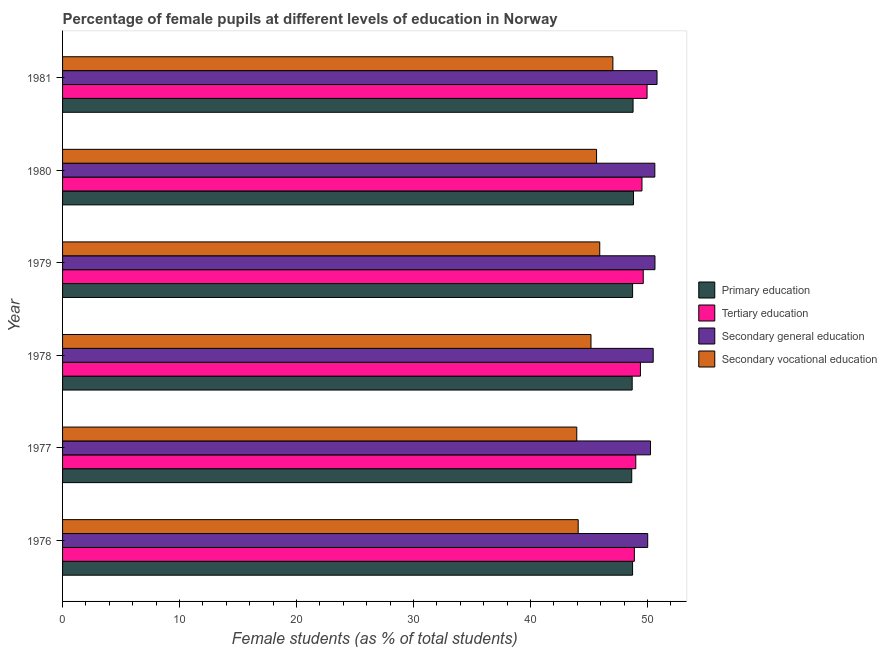How many different coloured bars are there?
Your answer should be very brief. 4. Are the number of bars per tick equal to the number of legend labels?
Offer a terse response. Yes. What is the label of the 6th group of bars from the top?
Provide a succinct answer. 1976. In how many cases, is the number of bars for a given year not equal to the number of legend labels?
Keep it short and to the point. 0. What is the percentage of female students in tertiary education in 1979?
Your response must be concise. 49.63. Across all years, what is the maximum percentage of female students in secondary vocational education?
Provide a short and direct response. 47.03. Across all years, what is the minimum percentage of female students in secondary vocational education?
Your answer should be very brief. 43.95. What is the total percentage of female students in secondary education in the graph?
Give a very brief answer. 302.8. What is the difference between the percentage of female students in primary education in 1977 and that in 1978?
Your answer should be very brief. -0.04. What is the difference between the percentage of female students in secondary education in 1979 and the percentage of female students in tertiary education in 1976?
Give a very brief answer. 1.76. What is the average percentage of female students in secondary education per year?
Your response must be concise. 50.47. In the year 1976, what is the difference between the percentage of female students in secondary vocational education and percentage of female students in secondary education?
Provide a short and direct response. -5.94. What is the difference between the highest and the second highest percentage of female students in secondary vocational education?
Your response must be concise. 1.12. What is the difference between the highest and the lowest percentage of female students in secondary vocational education?
Provide a short and direct response. 3.09. In how many years, is the percentage of female students in tertiary education greater than the average percentage of female students in tertiary education taken over all years?
Provide a succinct answer. 3. What does the 3rd bar from the top in 1977 represents?
Offer a terse response. Tertiary education. What does the 4th bar from the bottom in 1978 represents?
Your answer should be compact. Secondary vocational education. Are all the bars in the graph horizontal?
Give a very brief answer. Yes. How many years are there in the graph?
Offer a terse response. 6. What is the difference between two consecutive major ticks on the X-axis?
Make the answer very short. 10. Are the values on the major ticks of X-axis written in scientific E-notation?
Ensure brevity in your answer.  No. Does the graph contain any zero values?
Give a very brief answer. No. Where does the legend appear in the graph?
Ensure brevity in your answer.  Center right. How are the legend labels stacked?
Offer a very short reply. Vertical. What is the title of the graph?
Provide a short and direct response. Percentage of female pupils at different levels of education in Norway. Does "UNTA" appear as one of the legend labels in the graph?
Make the answer very short. No. What is the label or title of the X-axis?
Offer a terse response. Female students (as % of total students). What is the label or title of the Y-axis?
Your response must be concise. Year. What is the Female students (as % of total students) of Primary education in 1976?
Your answer should be compact. 48.72. What is the Female students (as % of total students) of Tertiary education in 1976?
Keep it short and to the point. 48.87. What is the Female students (as % of total students) in Secondary general education in 1976?
Offer a terse response. 50.01. What is the Female students (as % of total students) in Secondary vocational education in 1976?
Make the answer very short. 44.07. What is the Female students (as % of total students) in Primary education in 1977?
Keep it short and to the point. 48.65. What is the Female students (as % of total students) of Tertiary education in 1977?
Offer a terse response. 48.99. What is the Female students (as % of total students) of Secondary general education in 1977?
Give a very brief answer. 50.25. What is the Female students (as % of total students) of Secondary vocational education in 1977?
Keep it short and to the point. 43.95. What is the Female students (as % of total students) in Primary education in 1978?
Give a very brief answer. 48.68. What is the Female students (as % of total students) of Tertiary education in 1978?
Offer a very short reply. 49.39. What is the Female students (as % of total students) in Secondary general education in 1978?
Offer a very short reply. 50.48. What is the Female students (as % of total students) in Secondary vocational education in 1978?
Ensure brevity in your answer.  45.16. What is the Female students (as % of total students) in Primary education in 1979?
Provide a short and direct response. 48.72. What is the Female students (as % of total students) of Tertiary education in 1979?
Offer a terse response. 49.63. What is the Female students (as % of total students) in Secondary general education in 1979?
Offer a terse response. 50.63. What is the Female students (as % of total students) of Secondary vocational education in 1979?
Offer a very short reply. 45.91. What is the Female students (as % of total students) of Primary education in 1980?
Provide a short and direct response. 48.8. What is the Female students (as % of total students) in Tertiary education in 1980?
Keep it short and to the point. 49.52. What is the Female students (as % of total students) of Secondary general education in 1980?
Your answer should be very brief. 50.62. What is the Female students (as % of total students) in Secondary vocational education in 1980?
Your answer should be very brief. 45.64. What is the Female students (as % of total students) in Primary education in 1981?
Keep it short and to the point. 48.76. What is the Female students (as % of total students) in Tertiary education in 1981?
Provide a short and direct response. 49.96. What is the Female students (as % of total students) in Secondary general education in 1981?
Keep it short and to the point. 50.81. What is the Female students (as % of total students) of Secondary vocational education in 1981?
Your response must be concise. 47.03. Across all years, what is the maximum Female students (as % of total students) in Primary education?
Provide a short and direct response. 48.8. Across all years, what is the maximum Female students (as % of total students) in Tertiary education?
Ensure brevity in your answer.  49.96. Across all years, what is the maximum Female students (as % of total students) in Secondary general education?
Provide a short and direct response. 50.81. Across all years, what is the maximum Female students (as % of total students) of Secondary vocational education?
Your answer should be compact. 47.03. Across all years, what is the minimum Female students (as % of total students) of Primary education?
Your answer should be compact. 48.65. Across all years, what is the minimum Female students (as % of total students) in Tertiary education?
Offer a terse response. 48.87. Across all years, what is the minimum Female students (as % of total students) of Secondary general education?
Your answer should be very brief. 50.01. Across all years, what is the minimum Female students (as % of total students) of Secondary vocational education?
Your response must be concise. 43.95. What is the total Female students (as % of total students) of Primary education in the graph?
Give a very brief answer. 292.32. What is the total Female students (as % of total students) in Tertiary education in the graph?
Give a very brief answer. 296.35. What is the total Female students (as % of total students) of Secondary general education in the graph?
Ensure brevity in your answer.  302.8. What is the total Female students (as % of total students) in Secondary vocational education in the graph?
Keep it short and to the point. 271.76. What is the difference between the Female students (as % of total students) of Primary education in 1976 and that in 1977?
Make the answer very short. 0.07. What is the difference between the Female students (as % of total students) of Tertiary education in 1976 and that in 1977?
Ensure brevity in your answer.  -0.12. What is the difference between the Female students (as % of total students) of Secondary general education in 1976 and that in 1977?
Offer a terse response. -0.24. What is the difference between the Female students (as % of total students) in Secondary vocational education in 1976 and that in 1977?
Keep it short and to the point. 0.12. What is the difference between the Female students (as % of total students) of Primary education in 1976 and that in 1978?
Keep it short and to the point. 0.03. What is the difference between the Female students (as % of total students) in Tertiary education in 1976 and that in 1978?
Keep it short and to the point. -0.52. What is the difference between the Female students (as % of total students) of Secondary general education in 1976 and that in 1978?
Keep it short and to the point. -0.47. What is the difference between the Female students (as % of total students) in Secondary vocational education in 1976 and that in 1978?
Offer a terse response. -1.09. What is the difference between the Female students (as % of total students) of Primary education in 1976 and that in 1979?
Make the answer very short. -0. What is the difference between the Female students (as % of total students) in Tertiary education in 1976 and that in 1979?
Keep it short and to the point. -0.76. What is the difference between the Female students (as % of total students) in Secondary general education in 1976 and that in 1979?
Your answer should be compact. -0.62. What is the difference between the Female students (as % of total students) in Secondary vocational education in 1976 and that in 1979?
Offer a terse response. -1.84. What is the difference between the Female students (as % of total students) in Primary education in 1976 and that in 1980?
Ensure brevity in your answer.  -0.08. What is the difference between the Female students (as % of total students) of Tertiary education in 1976 and that in 1980?
Ensure brevity in your answer.  -0.65. What is the difference between the Female students (as % of total students) in Secondary general education in 1976 and that in 1980?
Offer a very short reply. -0.61. What is the difference between the Female students (as % of total students) in Secondary vocational education in 1976 and that in 1980?
Your response must be concise. -1.57. What is the difference between the Female students (as % of total students) in Primary education in 1976 and that in 1981?
Make the answer very short. -0.04. What is the difference between the Female students (as % of total students) of Tertiary education in 1976 and that in 1981?
Ensure brevity in your answer.  -1.09. What is the difference between the Female students (as % of total students) in Secondary general education in 1976 and that in 1981?
Offer a very short reply. -0.8. What is the difference between the Female students (as % of total students) of Secondary vocational education in 1976 and that in 1981?
Keep it short and to the point. -2.97. What is the difference between the Female students (as % of total students) in Primary education in 1977 and that in 1978?
Make the answer very short. -0.04. What is the difference between the Female students (as % of total students) in Tertiary education in 1977 and that in 1978?
Give a very brief answer. -0.4. What is the difference between the Female students (as % of total students) of Secondary general education in 1977 and that in 1978?
Offer a terse response. -0.23. What is the difference between the Female students (as % of total students) in Secondary vocational education in 1977 and that in 1978?
Your answer should be compact. -1.22. What is the difference between the Female students (as % of total students) in Primary education in 1977 and that in 1979?
Provide a succinct answer. -0.07. What is the difference between the Female students (as % of total students) of Tertiary education in 1977 and that in 1979?
Offer a terse response. -0.64. What is the difference between the Female students (as % of total students) of Secondary general education in 1977 and that in 1979?
Provide a succinct answer. -0.38. What is the difference between the Female students (as % of total students) of Secondary vocational education in 1977 and that in 1979?
Your answer should be compact. -1.96. What is the difference between the Female students (as % of total students) in Primary education in 1977 and that in 1980?
Your answer should be very brief. -0.15. What is the difference between the Female students (as % of total students) in Tertiary education in 1977 and that in 1980?
Your response must be concise. -0.53. What is the difference between the Female students (as % of total students) of Secondary general education in 1977 and that in 1980?
Keep it short and to the point. -0.37. What is the difference between the Female students (as % of total students) in Secondary vocational education in 1977 and that in 1980?
Your answer should be very brief. -1.69. What is the difference between the Female students (as % of total students) of Primary education in 1977 and that in 1981?
Provide a short and direct response. -0.11. What is the difference between the Female students (as % of total students) in Tertiary education in 1977 and that in 1981?
Give a very brief answer. -0.96. What is the difference between the Female students (as % of total students) in Secondary general education in 1977 and that in 1981?
Provide a short and direct response. -0.56. What is the difference between the Female students (as % of total students) in Secondary vocational education in 1977 and that in 1981?
Make the answer very short. -3.09. What is the difference between the Female students (as % of total students) in Primary education in 1978 and that in 1979?
Provide a short and direct response. -0.04. What is the difference between the Female students (as % of total students) in Tertiary education in 1978 and that in 1979?
Your response must be concise. -0.24. What is the difference between the Female students (as % of total students) in Secondary general education in 1978 and that in 1979?
Your response must be concise. -0.15. What is the difference between the Female students (as % of total students) of Secondary vocational education in 1978 and that in 1979?
Keep it short and to the point. -0.75. What is the difference between the Female students (as % of total students) of Primary education in 1978 and that in 1980?
Give a very brief answer. -0.11. What is the difference between the Female students (as % of total students) in Tertiary education in 1978 and that in 1980?
Provide a short and direct response. -0.13. What is the difference between the Female students (as % of total students) of Secondary general education in 1978 and that in 1980?
Make the answer very short. -0.14. What is the difference between the Female students (as % of total students) of Secondary vocational education in 1978 and that in 1980?
Ensure brevity in your answer.  -0.48. What is the difference between the Female students (as % of total students) of Primary education in 1978 and that in 1981?
Give a very brief answer. -0.08. What is the difference between the Female students (as % of total students) in Tertiary education in 1978 and that in 1981?
Your answer should be very brief. -0.57. What is the difference between the Female students (as % of total students) in Secondary general education in 1978 and that in 1981?
Your answer should be very brief. -0.33. What is the difference between the Female students (as % of total students) of Secondary vocational education in 1978 and that in 1981?
Offer a terse response. -1.87. What is the difference between the Female students (as % of total students) of Primary education in 1979 and that in 1980?
Offer a terse response. -0.08. What is the difference between the Female students (as % of total students) in Tertiary education in 1979 and that in 1980?
Offer a very short reply. 0.11. What is the difference between the Female students (as % of total students) of Secondary general education in 1979 and that in 1980?
Offer a very short reply. 0.01. What is the difference between the Female students (as % of total students) in Secondary vocational education in 1979 and that in 1980?
Provide a short and direct response. 0.27. What is the difference between the Female students (as % of total students) in Primary education in 1979 and that in 1981?
Your response must be concise. -0.04. What is the difference between the Female students (as % of total students) of Tertiary education in 1979 and that in 1981?
Your response must be concise. -0.33. What is the difference between the Female students (as % of total students) in Secondary general education in 1979 and that in 1981?
Your answer should be compact. -0.18. What is the difference between the Female students (as % of total students) in Secondary vocational education in 1979 and that in 1981?
Make the answer very short. -1.12. What is the difference between the Female students (as % of total students) in Primary education in 1980 and that in 1981?
Offer a very short reply. 0.04. What is the difference between the Female students (as % of total students) of Tertiary education in 1980 and that in 1981?
Provide a succinct answer. -0.44. What is the difference between the Female students (as % of total students) in Secondary general education in 1980 and that in 1981?
Your answer should be compact. -0.19. What is the difference between the Female students (as % of total students) in Secondary vocational education in 1980 and that in 1981?
Your answer should be very brief. -1.4. What is the difference between the Female students (as % of total students) in Primary education in 1976 and the Female students (as % of total students) in Tertiary education in 1977?
Give a very brief answer. -0.27. What is the difference between the Female students (as % of total students) of Primary education in 1976 and the Female students (as % of total students) of Secondary general education in 1977?
Your answer should be compact. -1.53. What is the difference between the Female students (as % of total students) in Primary education in 1976 and the Female students (as % of total students) in Secondary vocational education in 1977?
Your response must be concise. 4.77. What is the difference between the Female students (as % of total students) in Tertiary education in 1976 and the Female students (as % of total students) in Secondary general education in 1977?
Your answer should be very brief. -1.38. What is the difference between the Female students (as % of total students) in Tertiary education in 1976 and the Female students (as % of total students) in Secondary vocational education in 1977?
Ensure brevity in your answer.  4.92. What is the difference between the Female students (as % of total students) in Secondary general education in 1976 and the Female students (as % of total students) in Secondary vocational education in 1977?
Ensure brevity in your answer.  6.06. What is the difference between the Female students (as % of total students) in Primary education in 1976 and the Female students (as % of total students) in Tertiary education in 1978?
Give a very brief answer. -0.67. What is the difference between the Female students (as % of total students) of Primary education in 1976 and the Female students (as % of total students) of Secondary general education in 1978?
Provide a succinct answer. -1.76. What is the difference between the Female students (as % of total students) of Primary education in 1976 and the Female students (as % of total students) of Secondary vocational education in 1978?
Your response must be concise. 3.55. What is the difference between the Female students (as % of total students) in Tertiary education in 1976 and the Female students (as % of total students) in Secondary general education in 1978?
Offer a very short reply. -1.61. What is the difference between the Female students (as % of total students) in Tertiary education in 1976 and the Female students (as % of total students) in Secondary vocational education in 1978?
Provide a succinct answer. 3.71. What is the difference between the Female students (as % of total students) in Secondary general education in 1976 and the Female students (as % of total students) in Secondary vocational education in 1978?
Keep it short and to the point. 4.85. What is the difference between the Female students (as % of total students) of Primary education in 1976 and the Female students (as % of total students) of Tertiary education in 1979?
Provide a succinct answer. -0.91. What is the difference between the Female students (as % of total students) of Primary education in 1976 and the Female students (as % of total students) of Secondary general education in 1979?
Ensure brevity in your answer.  -1.91. What is the difference between the Female students (as % of total students) in Primary education in 1976 and the Female students (as % of total students) in Secondary vocational education in 1979?
Your response must be concise. 2.81. What is the difference between the Female students (as % of total students) in Tertiary education in 1976 and the Female students (as % of total students) in Secondary general education in 1979?
Your response must be concise. -1.76. What is the difference between the Female students (as % of total students) in Tertiary education in 1976 and the Female students (as % of total students) in Secondary vocational education in 1979?
Give a very brief answer. 2.96. What is the difference between the Female students (as % of total students) of Secondary general education in 1976 and the Female students (as % of total students) of Secondary vocational education in 1979?
Keep it short and to the point. 4.1. What is the difference between the Female students (as % of total students) in Primary education in 1976 and the Female students (as % of total students) in Tertiary education in 1980?
Offer a terse response. -0.8. What is the difference between the Female students (as % of total students) in Primary education in 1976 and the Female students (as % of total students) in Secondary general education in 1980?
Give a very brief answer. -1.9. What is the difference between the Female students (as % of total students) of Primary education in 1976 and the Female students (as % of total students) of Secondary vocational education in 1980?
Keep it short and to the point. 3.08. What is the difference between the Female students (as % of total students) of Tertiary education in 1976 and the Female students (as % of total students) of Secondary general education in 1980?
Ensure brevity in your answer.  -1.75. What is the difference between the Female students (as % of total students) of Tertiary education in 1976 and the Female students (as % of total students) of Secondary vocational education in 1980?
Offer a terse response. 3.23. What is the difference between the Female students (as % of total students) in Secondary general education in 1976 and the Female students (as % of total students) in Secondary vocational education in 1980?
Provide a succinct answer. 4.37. What is the difference between the Female students (as % of total students) of Primary education in 1976 and the Female students (as % of total students) of Tertiary education in 1981?
Give a very brief answer. -1.24. What is the difference between the Female students (as % of total students) in Primary education in 1976 and the Female students (as % of total students) in Secondary general education in 1981?
Keep it short and to the point. -2.09. What is the difference between the Female students (as % of total students) in Primary education in 1976 and the Female students (as % of total students) in Secondary vocational education in 1981?
Your response must be concise. 1.68. What is the difference between the Female students (as % of total students) of Tertiary education in 1976 and the Female students (as % of total students) of Secondary general education in 1981?
Give a very brief answer. -1.94. What is the difference between the Female students (as % of total students) of Tertiary education in 1976 and the Female students (as % of total students) of Secondary vocational education in 1981?
Your answer should be very brief. 1.84. What is the difference between the Female students (as % of total students) of Secondary general education in 1976 and the Female students (as % of total students) of Secondary vocational education in 1981?
Make the answer very short. 2.98. What is the difference between the Female students (as % of total students) in Primary education in 1977 and the Female students (as % of total students) in Tertiary education in 1978?
Provide a succinct answer. -0.74. What is the difference between the Female students (as % of total students) of Primary education in 1977 and the Female students (as % of total students) of Secondary general education in 1978?
Offer a terse response. -1.83. What is the difference between the Female students (as % of total students) in Primary education in 1977 and the Female students (as % of total students) in Secondary vocational education in 1978?
Provide a succinct answer. 3.48. What is the difference between the Female students (as % of total students) of Tertiary education in 1977 and the Female students (as % of total students) of Secondary general education in 1978?
Offer a terse response. -1.49. What is the difference between the Female students (as % of total students) in Tertiary education in 1977 and the Female students (as % of total students) in Secondary vocational education in 1978?
Your answer should be very brief. 3.83. What is the difference between the Female students (as % of total students) of Secondary general education in 1977 and the Female students (as % of total students) of Secondary vocational education in 1978?
Your answer should be compact. 5.09. What is the difference between the Female students (as % of total students) of Primary education in 1977 and the Female students (as % of total students) of Tertiary education in 1979?
Your response must be concise. -0.98. What is the difference between the Female students (as % of total students) of Primary education in 1977 and the Female students (as % of total students) of Secondary general education in 1979?
Your answer should be compact. -1.99. What is the difference between the Female students (as % of total students) of Primary education in 1977 and the Female students (as % of total students) of Secondary vocational education in 1979?
Offer a very short reply. 2.73. What is the difference between the Female students (as % of total students) in Tertiary education in 1977 and the Female students (as % of total students) in Secondary general education in 1979?
Give a very brief answer. -1.64. What is the difference between the Female students (as % of total students) in Tertiary education in 1977 and the Female students (as % of total students) in Secondary vocational education in 1979?
Provide a succinct answer. 3.08. What is the difference between the Female students (as % of total students) in Secondary general education in 1977 and the Female students (as % of total students) in Secondary vocational education in 1979?
Your answer should be very brief. 4.34. What is the difference between the Female students (as % of total students) in Primary education in 1977 and the Female students (as % of total students) in Tertiary education in 1980?
Keep it short and to the point. -0.87. What is the difference between the Female students (as % of total students) of Primary education in 1977 and the Female students (as % of total students) of Secondary general education in 1980?
Provide a short and direct response. -1.97. What is the difference between the Female students (as % of total students) in Primary education in 1977 and the Female students (as % of total students) in Secondary vocational education in 1980?
Your response must be concise. 3.01. What is the difference between the Female students (as % of total students) in Tertiary education in 1977 and the Female students (as % of total students) in Secondary general education in 1980?
Ensure brevity in your answer.  -1.63. What is the difference between the Female students (as % of total students) in Tertiary education in 1977 and the Female students (as % of total students) in Secondary vocational education in 1980?
Provide a short and direct response. 3.35. What is the difference between the Female students (as % of total students) of Secondary general education in 1977 and the Female students (as % of total students) of Secondary vocational education in 1980?
Make the answer very short. 4.61. What is the difference between the Female students (as % of total students) of Primary education in 1977 and the Female students (as % of total students) of Tertiary education in 1981?
Provide a succinct answer. -1.31. What is the difference between the Female students (as % of total students) in Primary education in 1977 and the Female students (as % of total students) in Secondary general education in 1981?
Provide a short and direct response. -2.16. What is the difference between the Female students (as % of total students) of Primary education in 1977 and the Female students (as % of total students) of Secondary vocational education in 1981?
Your answer should be compact. 1.61. What is the difference between the Female students (as % of total students) in Tertiary education in 1977 and the Female students (as % of total students) in Secondary general education in 1981?
Give a very brief answer. -1.82. What is the difference between the Female students (as % of total students) of Tertiary education in 1977 and the Female students (as % of total students) of Secondary vocational education in 1981?
Your answer should be very brief. 1.96. What is the difference between the Female students (as % of total students) of Secondary general education in 1977 and the Female students (as % of total students) of Secondary vocational education in 1981?
Make the answer very short. 3.21. What is the difference between the Female students (as % of total students) in Primary education in 1978 and the Female students (as % of total students) in Tertiary education in 1979?
Your answer should be compact. -0.95. What is the difference between the Female students (as % of total students) of Primary education in 1978 and the Female students (as % of total students) of Secondary general education in 1979?
Keep it short and to the point. -1.95. What is the difference between the Female students (as % of total students) of Primary education in 1978 and the Female students (as % of total students) of Secondary vocational education in 1979?
Ensure brevity in your answer.  2.77. What is the difference between the Female students (as % of total students) of Tertiary education in 1978 and the Female students (as % of total students) of Secondary general education in 1979?
Offer a terse response. -1.24. What is the difference between the Female students (as % of total students) in Tertiary education in 1978 and the Female students (as % of total students) in Secondary vocational education in 1979?
Your answer should be very brief. 3.48. What is the difference between the Female students (as % of total students) in Secondary general education in 1978 and the Female students (as % of total students) in Secondary vocational education in 1979?
Provide a succinct answer. 4.57. What is the difference between the Female students (as % of total students) in Primary education in 1978 and the Female students (as % of total students) in Tertiary education in 1980?
Give a very brief answer. -0.84. What is the difference between the Female students (as % of total students) in Primary education in 1978 and the Female students (as % of total students) in Secondary general education in 1980?
Offer a terse response. -1.94. What is the difference between the Female students (as % of total students) in Primary education in 1978 and the Female students (as % of total students) in Secondary vocational education in 1980?
Provide a succinct answer. 3.04. What is the difference between the Female students (as % of total students) of Tertiary education in 1978 and the Female students (as % of total students) of Secondary general education in 1980?
Provide a short and direct response. -1.23. What is the difference between the Female students (as % of total students) in Tertiary education in 1978 and the Female students (as % of total students) in Secondary vocational education in 1980?
Offer a terse response. 3.75. What is the difference between the Female students (as % of total students) of Secondary general education in 1978 and the Female students (as % of total students) of Secondary vocational education in 1980?
Your response must be concise. 4.84. What is the difference between the Female students (as % of total students) of Primary education in 1978 and the Female students (as % of total students) of Tertiary education in 1981?
Your response must be concise. -1.27. What is the difference between the Female students (as % of total students) of Primary education in 1978 and the Female students (as % of total students) of Secondary general education in 1981?
Make the answer very short. -2.12. What is the difference between the Female students (as % of total students) in Primary education in 1978 and the Female students (as % of total students) in Secondary vocational education in 1981?
Offer a terse response. 1.65. What is the difference between the Female students (as % of total students) in Tertiary education in 1978 and the Female students (as % of total students) in Secondary general education in 1981?
Your answer should be compact. -1.42. What is the difference between the Female students (as % of total students) of Tertiary education in 1978 and the Female students (as % of total students) of Secondary vocational education in 1981?
Your response must be concise. 2.35. What is the difference between the Female students (as % of total students) in Secondary general education in 1978 and the Female students (as % of total students) in Secondary vocational education in 1981?
Your answer should be compact. 3.45. What is the difference between the Female students (as % of total students) of Primary education in 1979 and the Female students (as % of total students) of Tertiary education in 1980?
Your response must be concise. -0.8. What is the difference between the Female students (as % of total students) of Primary education in 1979 and the Female students (as % of total students) of Secondary general education in 1980?
Make the answer very short. -1.9. What is the difference between the Female students (as % of total students) of Primary education in 1979 and the Female students (as % of total students) of Secondary vocational education in 1980?
Keep it short and to the point. 3.08. What is the difference between the Female students (as % of total students) of Tertiary education in 1979 and the Female students (as % of total students) of Secondary general education in 1980?
Your response must be concise. -0.99. What is the difference between the Female students (as % of total students) in Tertiary education in 1979 and the Female students (as % of total students) in Secondary vocational education in 1980?
Your answer should be compact. 3.99. What is the difference between the Female students (as % of total students) of Secondary general education in 1979 and the Female students (as % of total students) of Secondary vocational education in 1980?
Ensure brevity in your answer.  4.99. What is the difference between the Female students (as % of total students) in Primary education in 1979 and the Female students (as % of total students) in Tertiary education in 1981?
Ensure brevity in your answer.  -1.24. What is the difference between the Female students (as % of total students) in Primary education in 1979 and the Female students (as % of total students) in Secondary general education in 1981?
Ensure brevity in your answer.  -2.09. What is the difference between the Female students (as % of total students) of Primary education in 1979 and the Female students (as % of total students) of Secondary vocational education in 1981?
Ensure brevity in your answer.  1.68. What is the difference between the Female students (as % of total students) in Tertiary education in 1979 and the Female students (as % of total students) in Secondary general education in 1981?
Keep it short and to the point. -1.18. What is the difference between the Female students (as % of total students) of Tertiary education in 1979 and the Female students (as % of total students) of Secondary vocational education in 1981?
Your response must be concise. 2.59. What is the difference between the Female students (as % of total students) of Secondary general education in 1979 and the Female students (as % of total students) of Secondary vocational education in 1981?
Your response must be concise. 3.6. What is the difference between the Female students (as % of total students) of Primary education in 1980 and the Female students (as % of total students) of Tertiary education in 1981?
Keep it short and to the point. -1.16. What is the difference between the Female students (as % of total students) of Primary education in 1980 and the Female students (as % of total students) of Secondary general education in 1981?
Keep it short and to the point. -2.01. What is the difference between the Female students (as % of total students) in Primary education in 1980 and the Female students (as % of total students) in Secondary vocational education in 1981?
Ensure brevity in your answer.  1.76. What is the difference between the Female students (as % of total students) in Tertiary education in 1980 and the Female students (as % of total students) in Secondary general education in 1981?
Your answer should be compact. -1.29. What is the difference between the Female students (as % of total students) of Tertiary education in 1980 and the Female students (as % of total students) of Secondary vocational education in 1981?
Offer a very short reply. 2.48. What is the difference between the Female students (as % of total students) in Secondary general education in 1980 and the Female students (as % of total students) in Secondary vocational education in 1981?
Ensure brevity in your answer.  3.58. What is the average Female students (as % of total students) in Primary education per year?
Give a very brief answer. 48.72. What is the average Female students (as % of total students) in Tertiary education per year?
Offer a very short reply. 49.39. What is the average Female students (as % of total students) in Secondary general education per year?
Offer a terse response. 50.47. What is the average Female students (as % of total students) in Secondary vocational education per year?
Your response must be concise. 45.29. In the year 1976, what is the difference between the Female students (as % of total students) of Primary education and Female students (as % of total students) of Tertiary education?
Your response must be concise. -0.15. In the year 1976, what is the difference between the Female students (as % of total students) of Primary education and Female students (as % of total students) of Secondary general education?
Provide a succinct answer. -1.29. In the year 1976, what is the difference between the Female students (as % of total students) in Primary education and Female students (as % of total students) in Secondary vocational education?
Provide a succinct answer. 4.65. In the year 1976, what is the difference between the Female students (as % of total students) in Tertiary education and Female students (as % of total students) in Secondary general education?
Give a very brief answer. -1.14. In the year 1976, what is the difference between the Female students (as % of total students) of Tertiary education and Female students (as % of total students) of Secondary vocational education?
Your answer should be very brief. 4.8. In the year 1976, what is the difference between the Female students (as % of total students) in Secondary general education and Female students (as % of total students) in Secondary vocational education?
Give a very brief answer. 5.94. In the year 1977, what is the difference between the Female students (as % of total students) in Primary education and Female students (as % of total students) in Tertiary education?
Ensure brevity in your answer.  -0.35. In the year 1977, what is the difference between the Female students (as % of total students) in Primary education and Female students (as % of total students) in Secondary general education?
Your answer should be very brief. -1.6. In the year 1977, what is the difference between the Female students (as % of total students) of Primary education and Female students (as % of total students) of Secondary vocational education?
Your answer should be compact. 4.7. In the year 1977, what is the difference between the Female students (as % of total students) of Tertiary education and Female students (as % of total students) of Secondary general education?
Offer a very short reply. -1.26. In the year 1977, what is the difference between the Female students (as % of total students) in Tertiary education and Female students (as % of total students) in Secondary vocational education?
Your answer should be very brief. 5.04. In the year 1977, what is the difference between the Female students (as % of total students) in Secondary general education and Female students (as % of total students) in Secondary vocational education?
Your response must be concise. 6.3. In the year 1978, what is the difference between the Female students (as % of total students) in Primary education and Female students (as % of total students) in Tertiary education?
Offer a terse response. -0.7. In the year 1978, what is the difference between the Female students (as % of total students) of Primary education and Female students (as % of total students) of Secondary general education?
Offer a terse response. -1.8. In the year 1978, what is the difference between the Female students (as % of total students) in Primary education and Female students (as % of total students) in Secondary vocational education?
Make the answer very short. 3.52. In the year 1978, what is the difference between the Female students (as % of total students) of Tertiary education and Female students (as % of total students) of Secondary general education?
Make the answer very short. -1.09. In the year 1978, what is the difference between the Female students (as % of total students) of Tertiary education and Female students (as % of total students) of Secondary vocational education?
Give a very brief answer. 4.23. In the year 1978, what is the difference between the Female students (as % of total students) of Secondary general education and Female students (as % of total students) of Secondary vocational education?
Provide a short and direct response. 5.32. In the year 1979, what is the difference between the Female students (as % of total students) in Primary education and Female students (as % of total students) in Tertiary education?
Give a very brief answer. -0.91. In the year 1979, what is the difference between the Female students (as % of total students) of Primary education and Female students (as % of total students) of Secondary general education?
Your response must be concise. -1.91. In the year 1979, what is the difference between the Female students (as % of total students) of Primary education and Female students (as % of total students) of Secondary vocational education?
Give a very brief answer. 2.81. In the year 1979, what is the difference between the Female students (as % of total students) in Tertiary education and Female students (as % of total students) in Secondary general education?
Keep it short and to the point. -1. In the year 1979, what is the difference between the Female students (as % of total students) of Tertiary education and Female students (as % of total students) of Secondary vocational education?
Make the answer very short. 3.72. In the year 1979, what is the difference between the Female students (as % of total students) in Secondary general education and Female students (as % of total students) in Secondary vocational education?
Your answer should be compact. 4.72. In the year 1980, what is the difference between the Female students (as % of total students) of Primary education and Female students (as % of total students) of Tertiary education?
Offer a terse response. -0.72. In the year 1980, what is the difference between the Female students (as % of total students) in Primary education and Female students (as % of total students) in Secondary general education?
Your answer should be very brief. -1.82. In the year 1980, what is the difference between the Female students (as % of total students) in Primary education and Female students (as % of total students) in Secondary vocational education?
Your response must be concise. 3.16. In the year 1980, what is the difference between the Female students (as % of total students) of Tertiary education and Female students (as % of total students) of Secondary general education?
Provide a succinct answer. -1.1. In the year 1980, what is the difference between the Female students (as % of total students) in Tertiary education and Female students (as % of total students) in Secondary vocational education?
Make the answer very short. 3.88. In the year 1980, what is the difference between the Female students (as % of total students) of Secondary general education and Female students (as % of total students) of Secondary vocational education?
Your answer should be very brief. 4.98. In the year 1981, what is the difference between the Female students (as % of total students) in Primary education and Female students (as % of total students) in Tertiary education?
Offer a very short reply. -1.2. In the year 1981, what is the difference between the Female students (as % of total students) in Primary education and Female students (as % of total students) in Secondary general education?
Offer a terse response. -2.05. In the year 1981, what is the difference between the Female students (as % of total students) of Primary education and Female students (as % of total students) of Secondary vocational education?
Your response must be concise. 1.72. In the year 1981, what is the difference between the Female students (as % of total students) in Tertiary education and Female students (as % of total students) in Secondary general education?
Provide a succinct answer. -0.85. In the year 1981, what is the difference between the Female students (as % of total students) of Tertiary education and Female students (as % of total students) of Secondary vocational education?
Your answer should be very brief. 2.92. In the year 1981, what is the difference between the Female students (as % of total students) of Secondary general education and Female students (as % of total students) of Secondary vocational education?
Your answer should be compact. 3.77. What is the ratio of the Female students (as % of total students) of Primary education in 1976 to that in 1977?
Make the answer very short. 1. What is the ratio of the Female students (as % of total students) of Secondary vocational education in 1976 to that in 1977?
Offer a terse response. 1. What is the ratio of the Female students (as % of total students) of Tertiary education in 1976 to that in 1978?
Your answer should be very brief. 0.99. What is the ratio of the Female students (as % of total students) in Secondary general education in 1976 to that in 1978?
Your answer should be compact. 0.99. What is the ratio of the Female students (as % of total students) of Secondary vocational education in 1976 to that in 1978?
Provide a succinct answer. 0.98. What is the ratio of the Female students (as % of total students) in Primary education in 1976 to that in 1979?
Offer a terse response. 1. What is the ratio of the Female students (as % of total students) of Tertiary education in 1976 to that in 1979?
Ensure brevity in your answer.  0.98. What is the ratio of the Female students (as % of total students) in Secondary general education in 1976 to that in 1979?
Keep it short and to the point. 0.99. What is the ratio of the Female students (as % of total students) of Secondary vocational education in 1976 to that in 1979?
Make the answer very short. 0.96. What is the ratio of the Female students (as % of total students) of Primary education in 1976 to that in 1980?
Make the answer very short. 1. What is the ratio of the Female students (as % of total students) of Tertiary education in 1976 to that in 1980?
Give a very brief answer. 0.99. What is the ratio of the Female students (as % of total students) of Secondary vocational education in 1976 to that in 1980?
Provide a short and direct response. 0.97. What is the ratio of the Female students (as % of total students) in Tertiary education in 1976 to that in 1981?
Your response must be concise. 0.98. What is the ratio of the Female students (as % of total students) of Secondary general education in 1976 to that in 1981?
Your response must be concise. 0.98. What is the ratio of the Female students (as % of total students) of Secondary vocational education in 1976 to that in 1981?
Give a very brief answer. 0.94. What is the ratio of the Female students (as % of total students) of Tertiary education in 1977 to that in 1978?
Offer a very short reply. 0.99. What is the ratio of the Female students (as % of total students) of Secondary general education in 1977 to that in 1978?
Provide a succinct answer. 1. What is the ratio of the Female students (as % of total students) of Secondary vocational education in 1977 to that in 1978?
Offer a very short reply. 0.97. What is the ratio of the Female students (as % of total students) in Primary education in 1977 to that in 1979?
Provide a short and direct response. 1. What is the ratio of the Female students (as % of total students) of Tertiary education in 1977 to that in 1979?
Provide a succinct answer. 0.99. What is the ratio of the Female students (as % of total students) in Secondary general education in 1977 to that in 1979?
Your answer should be compact. 0.99. What is the ratio of the Female students (as % of total students) in Secondary vocational education in 1977 to that in 1979?
Offer a terse response. 0.96. What is the ratio of the Female students (as % of total students) of Tertiary education in 1977 to that in 1980?
Offer a very short reply. 0.99. What is the ratio of the Female students (as % of total students) in Secondary general education in 1977 to that in 1980?
Your answer should be very brief. 0.99. What is the ratio of the Female students (as % of total students) of Secondary vocational education in 1977 to that in 1980?
Ensure brevity in your answer.  0.96. What is the ratio of the Female students (as % of total students) of Tertiary education in 1977 to that in 1981?
Offer a terse response. 0.98. What is the ratio of the Female students (as % of total students) of Secondary general education in 1977 to that in 1981?
Your answer should be compact. 0.99. What is the ratio of the Female students (as % of total students) of Secondary vocational education in 1977 to that in 1981?
Provide a succinct answer. 0.93. What is the ratio of the Female students (as % of total students) in Primary education in 1978 to that in 1979?
Offer a terse response. 1. What is the ratio of the Female students (as % of total students) of Tertiary education in 1978 to that in 1979?
Make the answer very short. 1. What is the ratio of the Female students (as % of total students) in Secondary general education in 1978 to that in 1979?
Your response must be concise. 1. What is the ratio of the Female students (as % of total students) of Secondary vocational education in 1978 to that in 1979?
Offer a terse response. 0.98. What is the ratio of the Female students (as % of total students) of Primary education in 1978 to that in 1980?
Your answer should be very brief. 1. What is the ratio of the Female students (as % of total students) in Secondary vocational education in 1978 to that in 1980?
Your response must be concise. 0.99. What is the ratio of the Female students (as % of total students) of Tertiary education in 1978 to that in 1981?
Provide a short and direct response. 0.99. What is the ratio of the Female students (as % of total students) in Secondary vocational education in 1978 to that in 1981?
Your answer should be very brief. 0.96. What is the ratio of the Female students (as % of total students) in Secondary general education in 1979 to that in 1980?
Keep it short and to the point. 1. What is the ratio of the Female students (as % of total students) of Tertiary education in 1979 to that in 1981?
Offer a terse response. 0.99. What is the ratio of the Female students (as % of total students) in Secondary general education in 1979 to that in 1981?
Make the answer very short. 1. What is the ratio of the Female students (as % of total students) of Secondary vocational education in 1979 to that in 1981?
Make the answer very short. 0.98. What is the ratio of the Female students (as % of total students) in Primary education in 1980 to that in 1981?
Give a very brief answer. 1. What is the ratio of the Female students (as % of total students) of Tertiary education in 1980 to that in 1981?
Ensure brevity in your answer.  0.99. What is the ratio of the Female students (as % of total students) of Secondary general education in 1980 to that in 1981?
Provide a succinct answer. 1. What is the ratio of the Female students (as % of total students) in Secondary vocational education in 1980 to that in 1981?
Offer a very short reply. 0.97. What is the difference between the highest and the second highest Female students (as % of total students) of Primary education?
Keep it short and to the point. 0.04. What is the difference between the highest and the second highest Female students (as % of total students) of Tertiary education?
Ensure brevity in your answer.  0.33. What is the difference between the highest and the second highest Female students (as % of total students) of Secondary general education?
Ensure brevity in your answer.  0.18. What is the difference between the highest and the second highest Female students (as % of total students) in Secondary vocational education?
Make the answer very short. 1.12. What is the difference between the highest and the lowest Female students (as % of total students) of Primary education?
Provide a short and direct response. 0.15. What is the difference between the highest and the lowest Female students (as % of total students) in Tertiary education?
Provide a succinct answer. 1.09. What is the difference between the highest and the lowest Female students (as % of total students) of Secondary general education?
Your response must be concise. 0.8. What is the difference between the highest and the lowest Female students (as % of total students) of Secondary vocational education?
Your response must be concise. 3.09. 